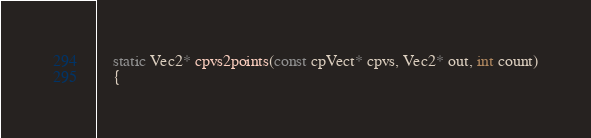<code> <loc_0><loc_0><loc_500><loc_500><_C_>    static Vec2* cpvs2points(const cpVect* cpvs, Vec2* out, int count)
    {</code> 